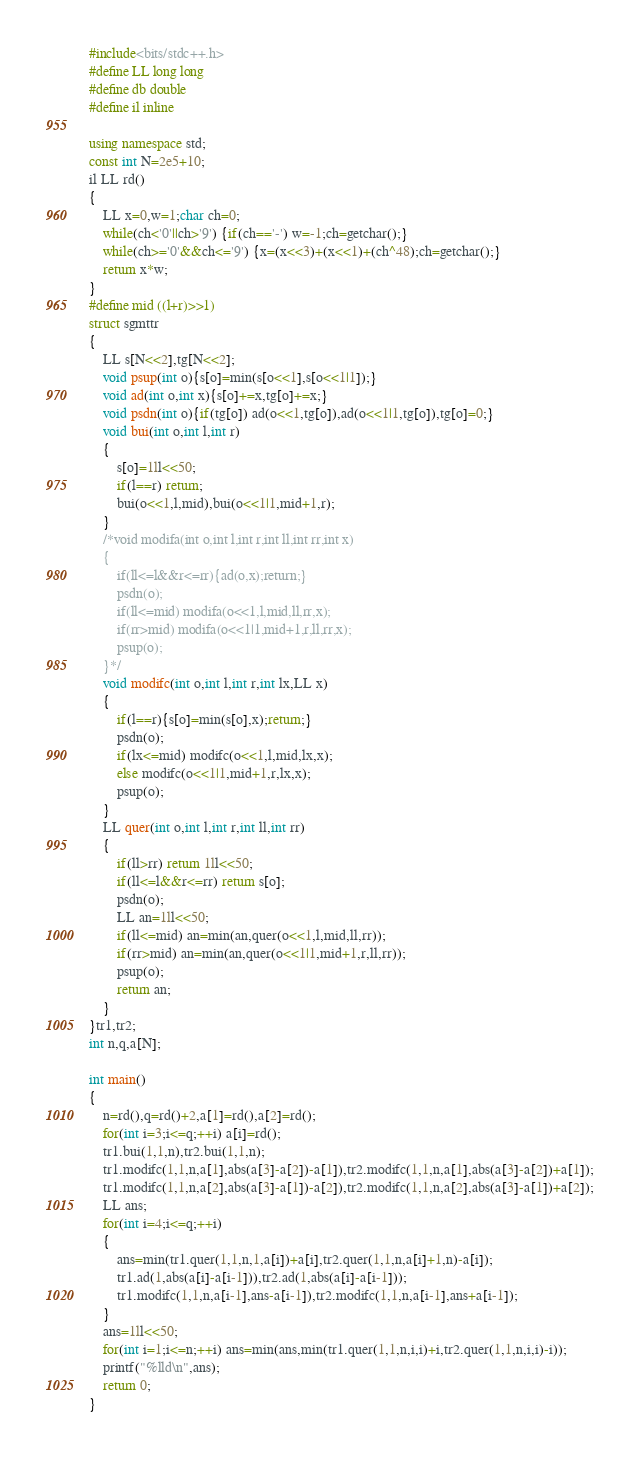Convert code to text. <code><loc_0><loc_0><loc_500><loc_500><_C++_>#include<bits/stdc++.h>
#define LL long long
#define db double
#define il inline

using namespace std;
const int N=2e5+10;
il LL rd()
{
    LL x=0,w=1;char ch=0;
    while(ch<'0'||ch>'9') {if(ch=='-') w=-1;ch=getchar();}
    while(ch>='0'&&ch<='9') {x=(x<<3)+(x<<1)+(ch^48);ch=getchar();}
    return x*w;
}
#define mid ((l+r)>>1)
struct sgmttr
{
	LL s[N<<2],tg[N<<2];
	void psup(int o){s[o]=min(s[o<<1],s[o<<1|1]);}
	void ad(int o,int x){s[o]+=x,tg[o]+=x;}
	void psdn(int o){if(tg[o]) ad(o<<1,tg[o]),ad(o<<1|1,tg[o]),tg[o]=0;}
	void bui(int o,int l,int r)
	{
		s[o]=1ll<<50;
		if(l==r) return;
		bui(o<<1,l,mid),bui(o<<1|1,mid+1,r);
	}
	/*void modifa(int o,int l,int r,int ll,int rr,int x)
	{
		if(ll<=l&&r<=rr){ad(o,x);return;}
		psdn(o);
		if(ll<=mid) modifa(o<<1,l,mid,ll,rr,x);
		if(rr>mid) modifa(o<<1|1,mid+1,r,ll,rr,x);
		psup(o);
	}*/
	void modifc(int o,int l,int r,int lx,LL x)
	{
		if(l==r){s[o]=min(s[o],x);return;}
		psdn(o);
		if(lx<=mid) modifc(o<<1,l,mid,lx,x);
		else modifc(o<<1|1,mid+1,r,lx,x);
		psup(o);
	}
	LL quer(int o,int l,int r,int ll,int rr)
	{
		if(ll>rr) return 1ll<<50;
		if(ll<=l&&r<=rr) return s[o];
		psdn(o);
		LL an=1ll<<50;
		if(ll<=mid) an=min(an,quer(o<<1,l,mid,ll,rr));
		if(rr>mid) an=min(an,quer(o<<1|1,mid+1,r,ll,rr));
		psup(o);
		return an;
	}
}tr1,tr2;
int n,q,a[N];

int main()
{
	n=rd(),q=rd()+2,a[1]=rd(),a[2]=rd();
	for(int i=3;i<=q;++i) a[i]=rd();
	tr1.bui(1,1,n),tr2.bui(1,1,n);
	tr1.modifc(1,1,n,a[1],abs(a[3]-a[2])-a[1]),tr2.modifc(1,1,n,a[1],abs(a[3]-a[2])+a[1]);
	tr1.modifc(1,1,n,a[2],abs(a[3]-a[1])-a[2]),tr2.modifc(1,1,n,a[2],abs(a[3]-a[1])+a[2]);
	LL ans;
	for(int i=4;i<=q;++i)
	{
		ans=min(tr1.quer(1,1,n,1,a[i])+a[i],tr2.quer(1,1,n,a[i]+1,n)-a[i]);
		tr1.ad(1,abs(a[i]-a[i-1])),tr2.ad(1,abs(a[i]-a[i-1]));
		tr1.modifc(1,1,n,a[i-1],ans-a[i-1]),tr2.modifc(1,1,n,a[i-1],ans+a[i-1]);
	}
	ans=1ll<<50;
	for(int i=1;i<=n;++i) ans=min(ans,min(tr1.quer(1,1,n,i,i)+i,tr2.quer(1,1,n,i,i)-i));
	printf("%lld\n",ans);
    return 0; 
}
</code> 